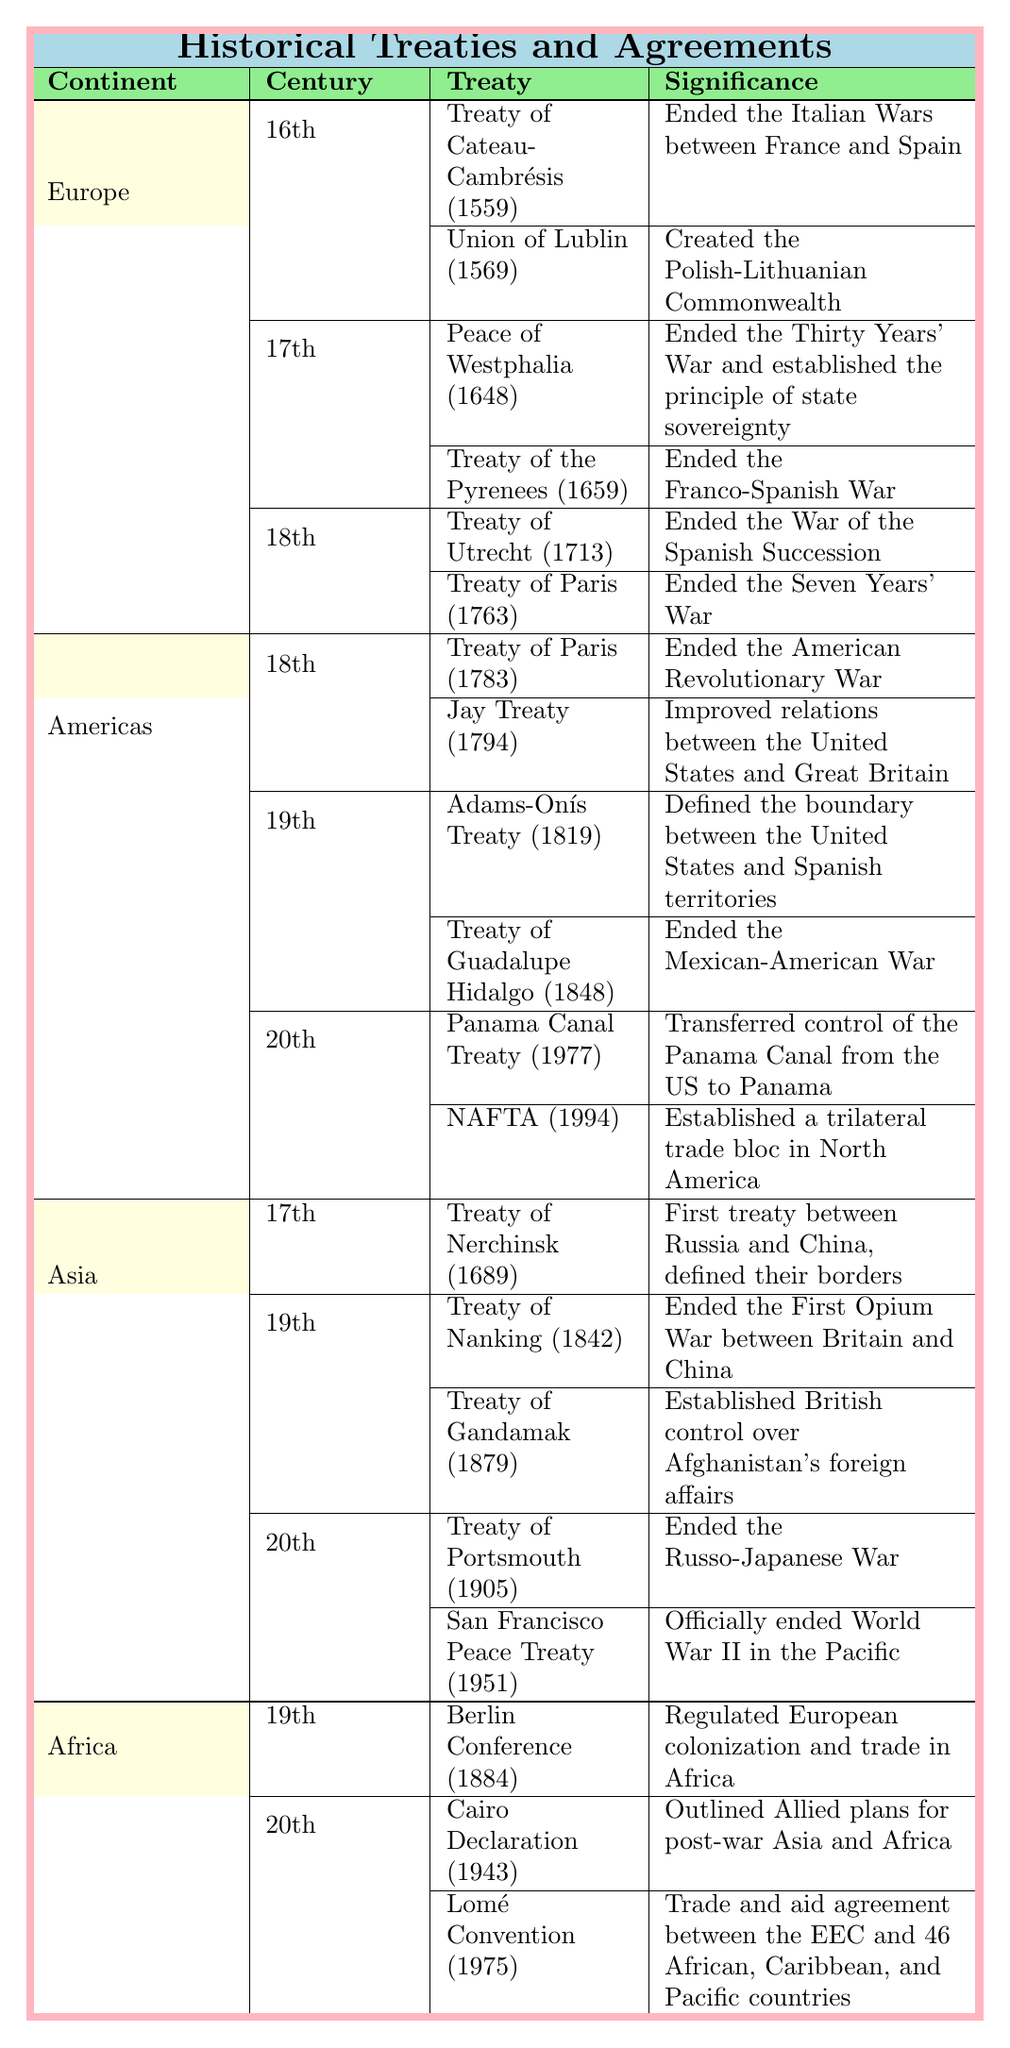What treaty ended the Italian Wars in Europe? The table states that the Treaty of Cateau-Cambrésis, signed in 1559, ended the Italian Wars between France and Spain.
Answer: Treaty of Cateau-Cambrésis Which continent had treaties recorded in the 20th century? The table shows that both the Americas and Asia have treaties recorded in the 20th century, specifically the Panama Canal Treaty and NAFTA for the Americas, and the Treaty of Portsmouth and San Francisco Peace Treaty for Asia.
Answer: Americas and Asia How many treaties were signed in the 19th century in Asia? The table indicates two treaties were signed in the 19th century in Asia: the Treaty of Nanking (1842) and the Treaty of Gandamak (1879). Since both are listed, the total count is 2.
Answer: 2 Was the Treaty of Paris mentioned more than once in the table? The table lists two instances of the Treaty of Paris: one in the 18th century related to the American Revolutionary War and another in the 18th century related to the Seven Years' War in Europe.
Answer: Yes Which treaty established the Polish-Lithuanian Commonwealth? According to the table, the Union of Lublin, signed in 1569, created the Polish-Lithuanian Commonwealth.
Answer: Union of Lublin What is the significance of the Treaty of Guadalupe Hidalgo? The table states that the Treaty of Guadalupe Hidalgo, signed in 1848, ended the Mexican-American War.
Answer: Ended the Mexican-American War How do the number of treaties in the 18th century in the Americas compare to those in Europe? The table shows that the Americas have 2 treaties in the 18th century (Treaty of Paris in 1783 and Jay Treaty in 1794) while Europe also has 2 treaties (Treaty of Utrecht in 1713 and Treaty of Paris in 1763), making them equal.
Answer: They are equal Which treaty marked the end of the Thirty Years' War? The table notes that the Peace of Westphalia, signed in 1648, ended the Thirty Years' War.
Answer: Peace of Westphalia How many total treaties are listed for Africa? The table shows one treaty from the 19th century, the Berlin Conference (1884), and two treaties from the 20th century (Cairo Declaration in 1943 and Lomé Convention in 1975), adding up to a total of three treaties.
Answer: 3 What is the significance of the Cairo Declaration? The table states that the Cairo Declaration, signed in 1943, outlined Allied plans for post-war Asia and Africa.
Answer: Outlined Allied plans for post-war Asia and Africa 